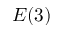<formula> <loc_0><loc_0><loc_500><loc_500>E ( 3 )</formula> 